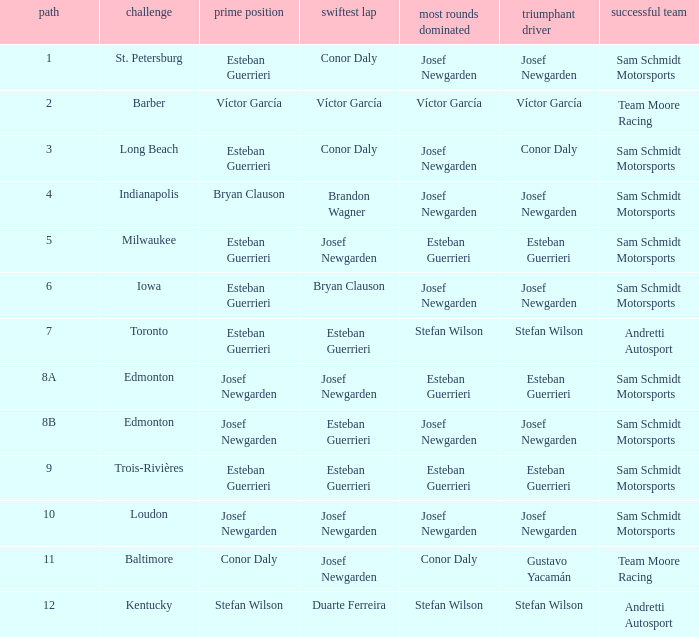Who led the most laps when brandon wagner had the fastest lap? Josef Newgarden. 